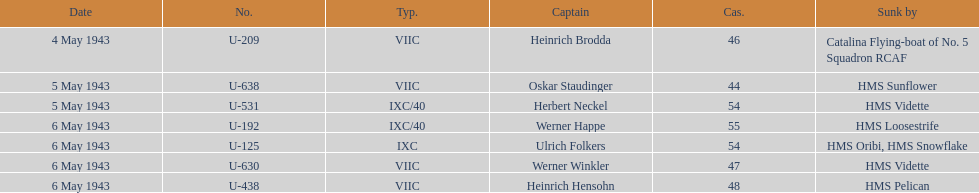Aside from oskar staudinger what was the name of the other captain of the u-boat loast on may 5? Herbert Neckel. 